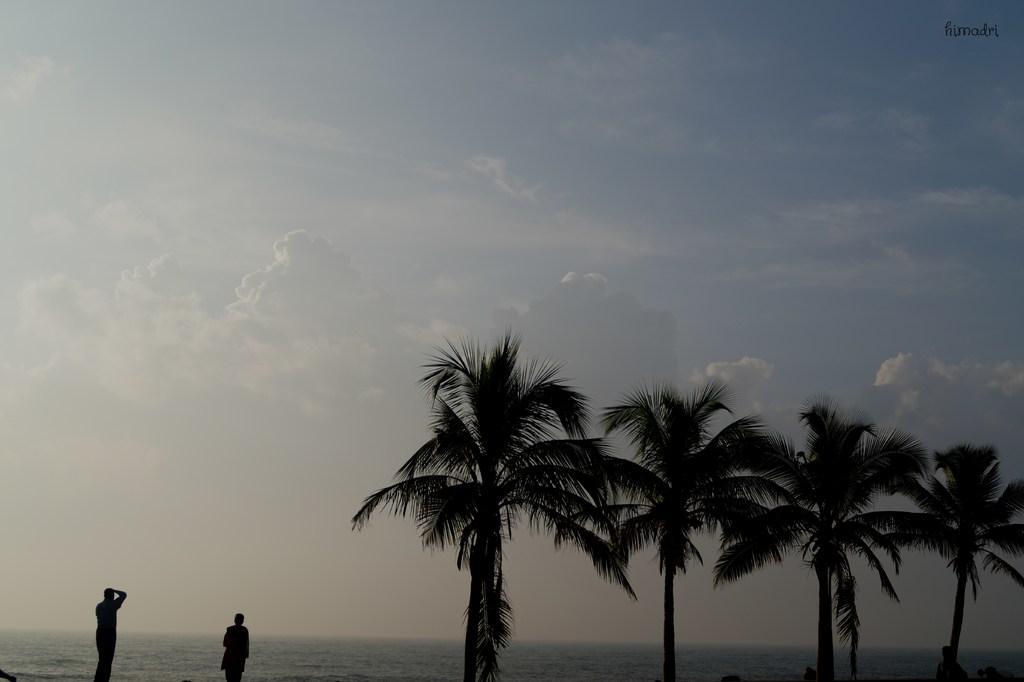In one or two sentences, can you explain what this image depicts? There are two people standing and we can trees. In the background we can see water and sky with clouds. 